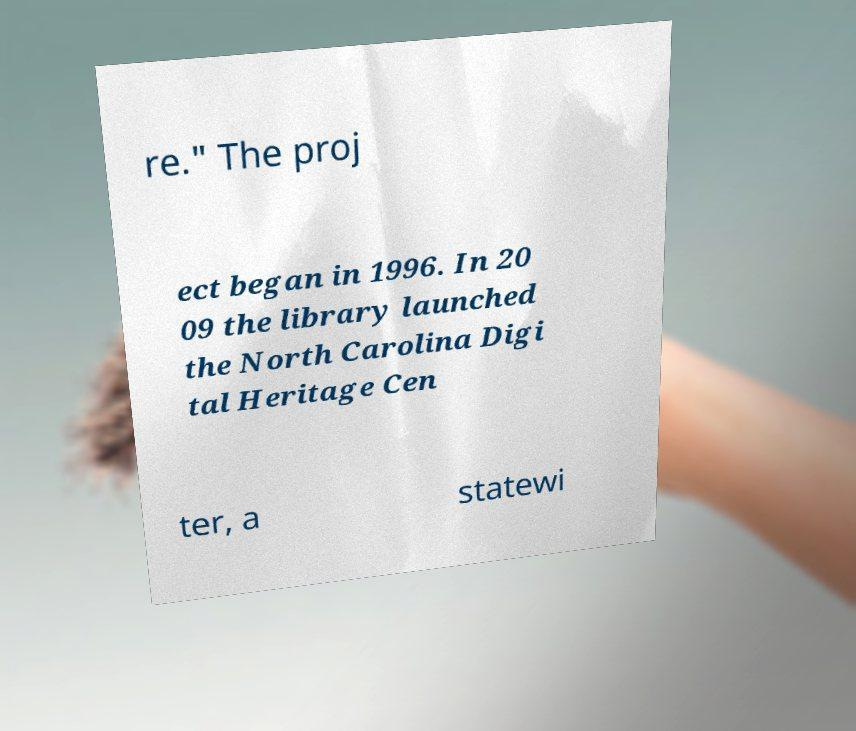Please identify and transcribe the text found in this image. re." The proj ect began in 1996. In 20 09 the library launched the North Carolina Digi tal Heritage Cen ter, a statewi 